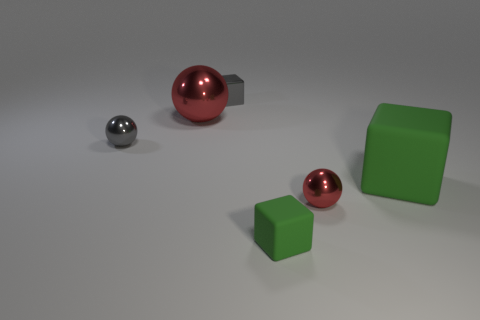Is there anything else that is the same shape as the big matte thing?
Offer a terse response. Yes. What shape is the red thing to the right of the block behind the small gray shiny ball?
Offer a very short reply. Sphere. What is the shape of the tiny object that is made of the same material as the large green block?
Your response must be concise. Cube. How big is the block that is in front of the large rubber object in front of the small gray cube?
Provide a succinct answer. Small. The tiny green matte object has what shape?
Provide a short and direct response. Cube. How many small objects are either red shiny things or gray objects?
Ensure brevity in your answer.  3. What size is the other red shiny object that is the same shape as the small red thing?
Give a very brief answer. Large. How many blocks are left of the big block and in front of the metal cube?
Your answer should be very brief. 1. There is a large red metal object; does it have the same shape as the green object behind the small green rubber block?
Your answer should be very brief. No. Is the number of big green objects right of the tiny gray metallic block greater than the number of large red rubber objects?
Your answer should be very brief. Yes. 